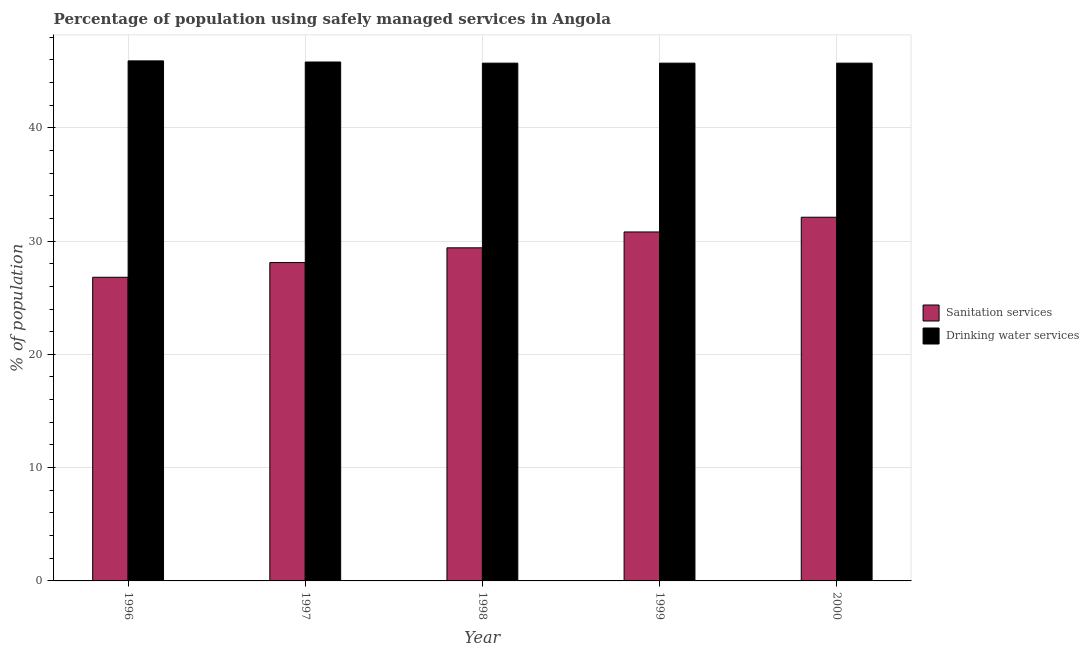How many groups of bars are there?
Provide a succinct answer. 5. How many bars are there on the 3rd tick from the left?
Keep it short and to the point. 2. How many bars are there on the 5th tick from the right?
Ensure brevity in your answer.  2. What is the percentage of population who used drinking water services in 1999?
Your answer should be compact. 45.7. Across all years, what is the maximum percentage of population who used drinking water services?
Your answer should be compact. 45.9. Across all years, what is the minimum percentage of population who used drinking water services?
Give a very brief answer. 45.7. In which year was the percentage of population who used sanitation services minimum?
Provide a succinct answer. 1996. What is the total percentage of population who used drinking water services in the graph?
Your answer should be compact. 228.8. What is the difference between the percentage of population who used drinking water services in 1996 and that in 2000?
Offer a very short reply. 0.2. What is the difference between the percentage of population who used drinking water services in 2000 and the percentage of population who used sanitation services in 1997?
Make the answer very short. -0.1. What is the average percentage of population who used drinking water services per year?
Your response must be concise. 45.76. In the year 1998, what is the difference between the percentage of population who used sanitation services and percentage of population who used drinking water services?
Your answer should be very brief. 0. In how many years, is the percentage of population who used sanitation services greater than 44 %?
Keep it short and to the point. 0. What is the ratio of the percentage of population who used sanitation services in 1997 to that in 2000?
Your answer should be very brief. 0.88. Is the difference between the percentage of population who used sanitation services in 1999 and 2000 greater than the difference between the percentage of population who used drinking water services in 1999 and 2000?
Your answer should be very brief. No. What is the difference between the highest and the second highest percentage of population who used drinking water services?
Make the answer very short. 0.1. What is the difference between the highest and the lowest percentage of population who used sanitation services?
Your response must be concise. 5.3. In how many years, is the percentage of population who used sanitation services greater than the average percentage of population who used sanitation services taken over all years?
Offer a very short reply. 2. What does the 2nd bar from the left in 1998 represents?
Give a very brief answer. Drinking water services. What does the 1st bar from the right in 2000 represents?
Ensure brevity in your answer.  Drinking water services. Where does the legend appear in the graph?
Your answer should be compact. Center right. How many legend labels are there?
Provide a succinct answer. 2. How are the legend labels stacked?
Keep it short and to the point. Vertical. What is the title of the graph?
Offer a terse response. Percentage of population using safely managed services in Angola. Does "% of gross capital formation" appear as one of the legend labels in the graph?
Your answer should be compact. No. What is the label or title of the Y-axis?
Give a very brief answer. % of population. What is the % of population in Sanitation services in 1996?
Your answer should be compact. 26.8. What is the % of population in Drinking water services in 1996?
Provide a short and direct response. 45.9. What is the % of population of Sanitation services in 1997?
Keep it short and to the point. 28.1. What is the % of population in Drinking water services in 1997?
Give a very brief answer. 45.8. What is the % of population in Sanitation services in 1998?
Give a very brief answer. 29.4. What is the % of population of Drinking water services in 1998?
Provide a succinct answer. 45.7. What is the % of population of Sanitation services in 1999?
Offer a terse response. 30.8. What is the % of population of Drinking water services in 1999?
Provide a succinct answer. 45.7. What is the % of population in Sanitation services in 2000?
Ensure brevity in your answer.  32.1. What is the % of population of Drinking water services in 2000?
Your answer should be compact. 45.7. Across all years, what is the maximum % of population of Sanitation services?
Your answer should be compact. 32.1. Across all years, what is the maximum % of population of Drinking water services?
Your response must be concise. 45.9. Across all years, what is the minimum % of population of Sanitation services?
Keep it short and to the point. 26.8. Across all years, what is the minimum % of population in Drinking water services?
Provide a short and direct response. 45.7. What is the total % of population of Sanitation services in the graph?
Your answer should be very brief. 147.2. What is the total % of population in Drinking water services in the graph?
Your response must be concise. 228.8. What is the difference between the % of population in Sanitation services in 1996 and that in 1998?
Provide a short and direct response. -2.6. What is the difference between the % of population in Drinking water services in 1996 and that in 1998?
Give a very brief answer. 0.2. What is the difference between the % of population in Sanitation services in 1996 and that in 1999?
Offer a terse response. -4. What is the difference between the % of population in Sanitation services in 1996 and that in 2000?
Your response must be concise. -5.3. What is the difference between the % of population in Drinking water services in 1996 and that in 2000?
Offer a terse response. 0.2. What is the difference between the % of population in Drinking water services in 1997 and that in 1999?
Offer a very short reply. 0.1. What is the difference between the % of population of Sanitation services in 1998 and that in 1999?
Your answer should be very brief. -1.4. What is the difference between the % of population of Drinking water services in 1998 and that in 1999?
Provide a succinct answer. 0. What is the difference between the % of population of Drinking water services in 1998 and that in 2000?
Make the answer very short. 0. What is the difference between the % of population of Sanitation services in 1999 and that in 2000?
Your response must be concise. -1.3. What is the difference between the % of population in Drinking water services in 1999 and that in 2000?
Ensure brevity in your answer.  0. What is the difference between the % of population in Sanitation services in 1996 and the % of population in Drinking water services in 1997?
Provide a succinct answer. -19. What is the difference between the % of population of Sanitation services in 1996 and the % of population of Drinking water services in 1998?
Your answer should be very brief. -18.9. What is the difference between the % of population in Sanitation services in 1996 and the % of population in Drinking water services in 1999?
Your answer should be very brief. -18.9. What is the difference between the % of population of Sanitation services in 1996 and the % of population of Drinking water services in 2000?
Your answer should be compact. -18.9. What is the difference between the % of population in Sanitation services in 1997 and the % of population in Drinking water services in 1998?
Make the answer very short. -17.6. What is the difference between the % of population of Sanitation services in 1997 and the % of population of Drinking water services in 1999?
Keep it short and to the point. -17.6. What is the difference between the % of population of Sanitation services in 1997 and the % of population of Drinking water services in 2000?
Give a very brief answer. -17.6. What is the difference between the % of population of Sanitation services in 1998 and the % of population of Drinking water services in 1999?
Your answer should be very brief. -16.3. What is the difference between the % of population of Sanitation services in 1998 and the % of population of Drinking water services in 2000?
Keep it short and to the point. -16.3. What is the difference between the % of population of Sanitation services in 1999 and the % of population of Drinking water services in 2000?
Offer a very short reply. -14.9. What is the average % of population in Sanitation services per year?
Ensure brevity in your answer.  29.44. What is the average % of population of Drinking water services per year?
Your answer should be very brief. 45.76. In the year 1996, what is the difference between the % of population of Sanitation services and % of population of Drinking water services?
Offer a very short reply. -19.1. In the year 1997, what is the difference between the % of population of Sanitation services and % of population of Drinking water services?
Provide a succinct answer. -17.7. In the year 1998, what is the difference between the % of population in Sanitation services and % of population in Drinking water services?
Provide a short and direct response. -16.3. In the year 1999, what is the difference between the % of population of Sanitation services and % of population of Drinking water services?
Make the answer very short. -14.9. In the year 2000, what is the difference between the % of population of Sanitation services and % of population of Drinking water services?
Provide a short and direct response. -13.6. What is the ratio of the % of population in Sanitation services in 1996 to that in 1997?
Your response must be concise. 0.95. What is the ratio of the % of population in Drinking water services in 1996 to that in 1997?
Give a very brief answer. 1. What is the ratio of the % of population of Sanitation services in 1996 to that in 1998?
Offer a terse response. 0.91. What is the ratio of the % of population in Sanitation services in 1996 to that in 1999?
Provide a succinct answer. 0.87. What is the ratio of the % of population in Drinking water services in 1996 to that in 1999?
Offer a very short reply. 1. What is the ratio of the % of population of Sanitation services in 1996 to that in 2000?
Make the answer very short. 0.83. What is the ratio of the % of population of Sanitation services in 1997 to that in 1998?
Give a very brief answer. 0.96. What is the ratio of the % of population of Drinking water services in 1997 to that in 1998?
Provide a short and direct response. 1. What is the ratio of the % of population of Sanitation services in 1997 to that in 1999?
Offer a terse response. 0.91. What is the ratio of the % of population in Drinking water services in 1997 to that in 1999?
Your answer should be very brief. 1. What is the ratio of the % of population in Sanitation services in 1997 to that in 2000?
Give a very brief answer. 0.88. What is the ratio of the % of population of Drinking water services in 1997 to that in 2000?
Offer a terse response. 1. What is the ratio of the % of population of Sanitation services in 1998 to that in 1999?
Your response must be concise. 0.95. What is the ratio of the % of population of Drinking water services in 1998 to that in 1999?
Make the answer very short. 1. What is the ratio of the % of population of Sanitation services in 1998 to that in 2000?
Provide a succinct answer. 0.92. What is the ratio of the % of population in Drinking water services in 1998 to that in 2000?
Your answer should be compact. 1. What is the ratio of the % of population in Sanitation services in 1999 to that in 2000?
Your answer should be compact. 0.96. What is the difference between the highest and the second highest % of population of Sanitation services?
Give a very brief answer. 1.3. 